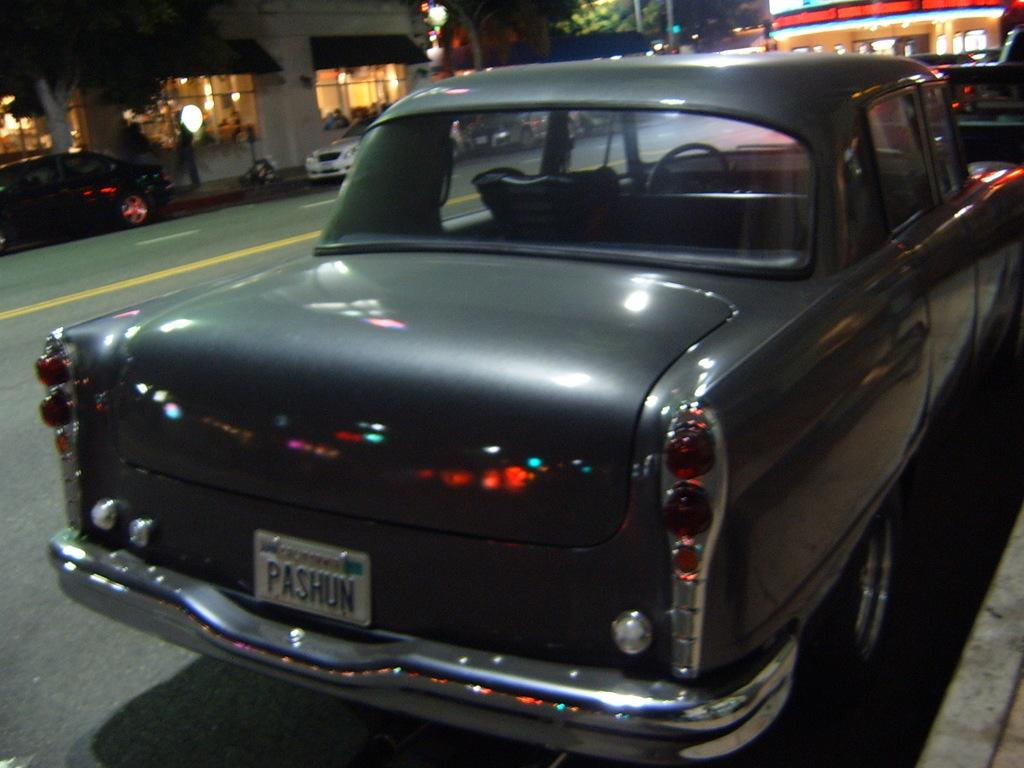What can be seen on the road in the image? There are vehicles parked on the road in the image. What is visible behind the vehicles? There are trees and buildings visible behind the vehicles. What type of nation is depicted in the image? The image does not depict a nation; it shows vehicles parked on a road with trees and buildings in the background. 